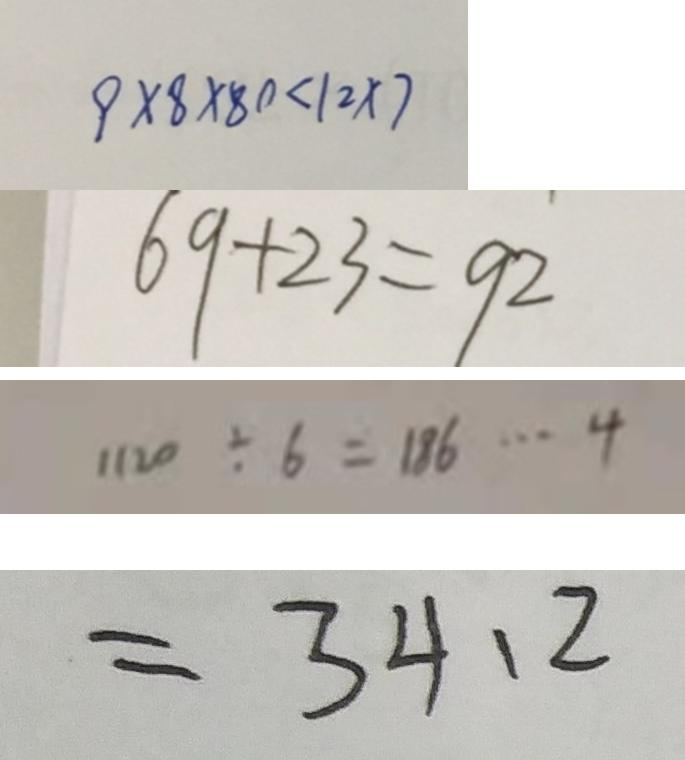Convert formula to latex. <formula><loc_0><loc_0><loc_500><loc_500>9 \times 8 \times 8 0 < 1 2 \times 7 
 6 9 + 2 3 = 9 2 
 1 1 2 0 \div 6 = 1 8 6 \cdots 4 
 = 3 4 . 2</formula> 